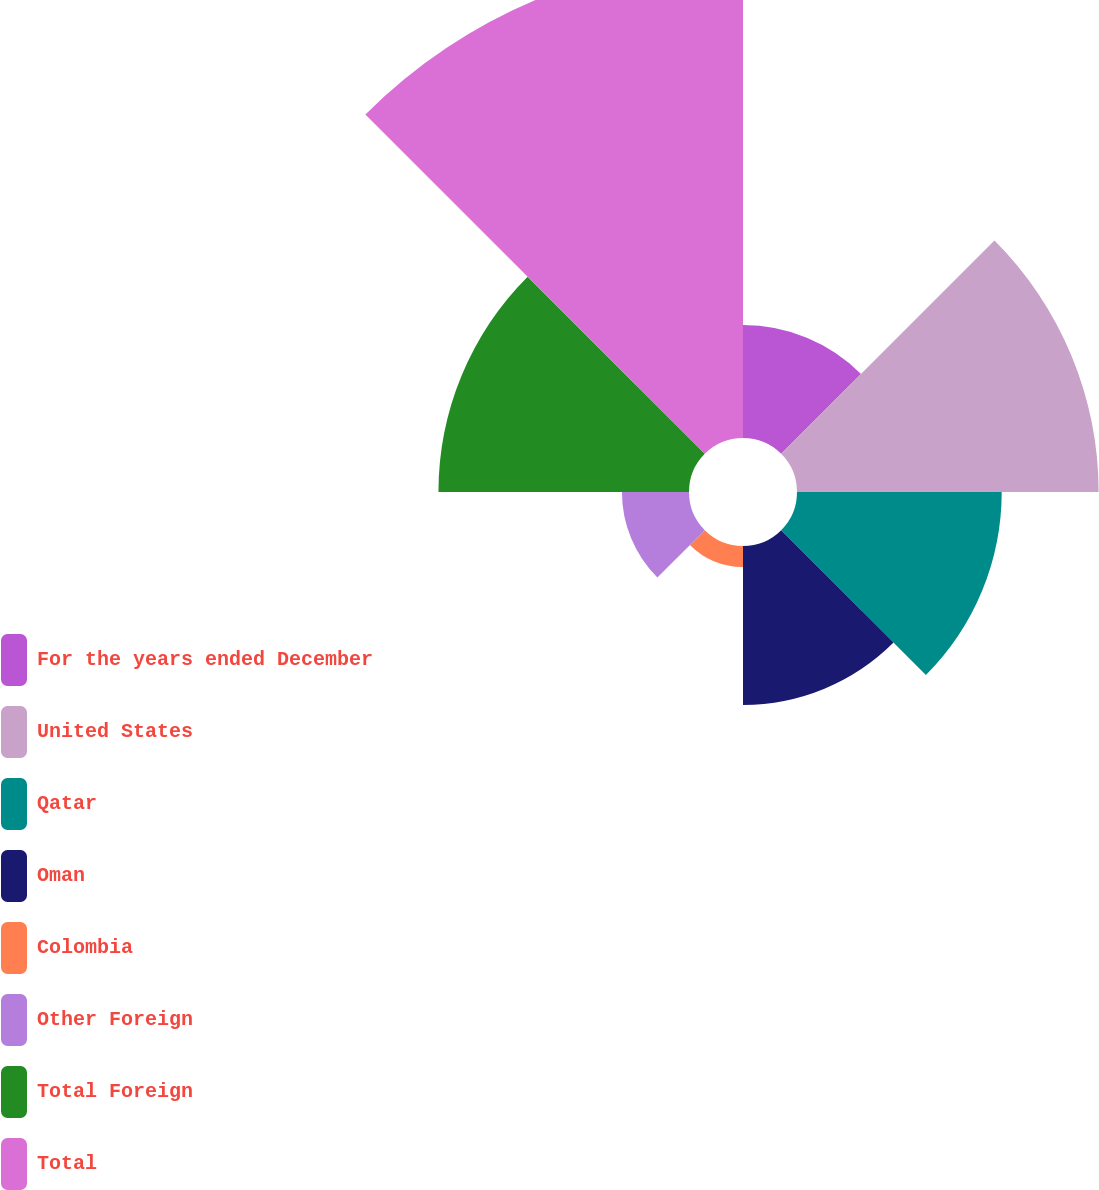<chart> <loc_0><loc_0><loc_500><loc_500><pie_chart><fcel>For the years ended December<fcel>United States<fcel>Qatar<fcel>Oman<fcel>Colombia<fcel>Other Foreign<fcel>Total Foreign<fcel>Total<nl><fcel>7.07%<fcel>18.89%<fcel>12.82%<fcel>9.95%<fcel>1.32%<fcel>4.2%<fcel>15.69%<fcel>30.06%<nl></chart> 